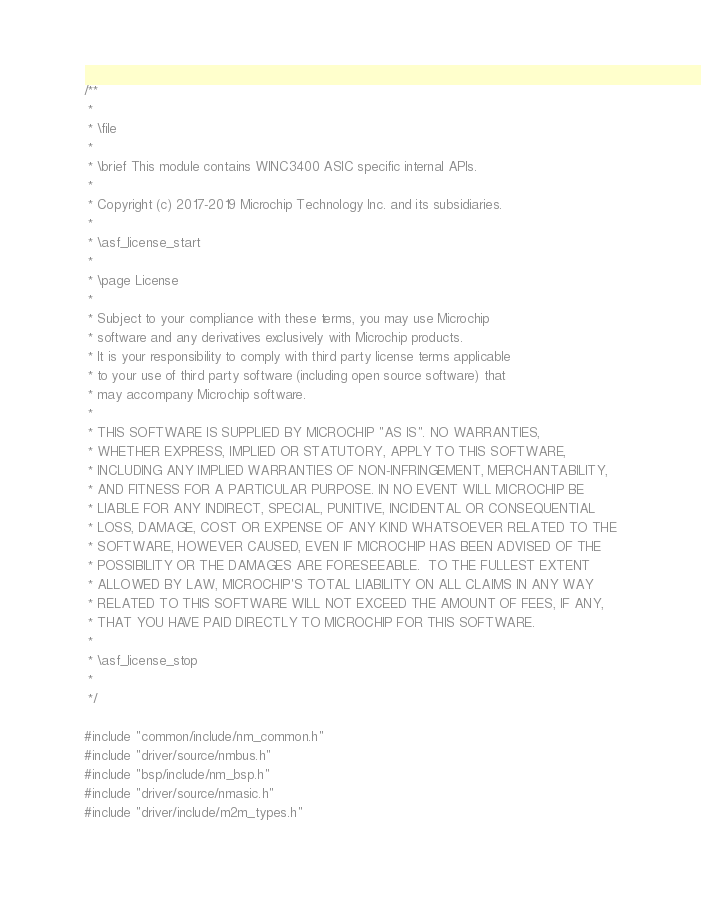<code> <loc_0><loc_0><loc_500><loc_500><_C_>/**
 *
 * \file
 *
 * \brief This module contains WINC3400 ASIC specific internal APIs.
 *
 * Copyright (c) 2017-2019 Microchip Technology Inc. and its subsidiaries.
 *
 * \asf_license_start
 *
 * \page License
 *
 * Subject to your compliance with these terms, you may use Microchip
 * software and any derivatives exclusively with Microchip products.
 * It is your responsibility to comply with third party license terms applicable
 * to your use of third party software (including open source software) that
 * may accompany Microchip software.
 *
 * THIS SOFTWARE IS SUPPLIED BY MICROCHIP "AS IS". NO WARRANTIES,
 * WHETHER EXPRESS, IMPLIED OR STATUTORY, APPLY TO THIS SOFTWARE,
 * INCLUDING ANY IMPLIED WARRANTIES OF NON-INFRINGEMENT, MERCHANTABILITY,
 * AND FITNESS FOR A PARTICULAR PURPOSE. IN NO EVENT WILL MICROCHIP BE
 * LIABLE FOR ANY INDIRECT, SPECIAL, PUNITIVE, INCIDENTAL OR CONSEQUENTIAL
 * LOSS, DAMAGE, COST OR EXPENSE OF ANY KIND WHATSOEVER RELATED TO THE
 * SOFTWARE, HOWEVER CAUSED, EVEN IF MICROCHIP HAS BEEN ADVISED OF THE
 * POSSIBILITY OR THE DAMAGES ARE FORESEEABLE.  TO THE FULLEST EXTENT
 * ALLOWED BY LAW, MICROCHIP'S TOTAL LIABILITY ON ALL CLAIMS IN ANY WAY
 * RELATED TO THIS SOFTWARE WILL NOT EXCEED THE AMOUNT OF FEES, IF ANY,
 * THAT YOU HAVE PAID DIRECTLY TO MICROCHIP FOR THIS SOFTWARE.
 *
 * \asf_license_stop
 *
 */

#include "common/include/nm_common.h"
#include "driver/source/nmbus.h"
#include "bsp/include/nm_bsp.h"
#include "driver/source/nmasic.h"
#include "driver/include/m2m_types.h"
</code> 